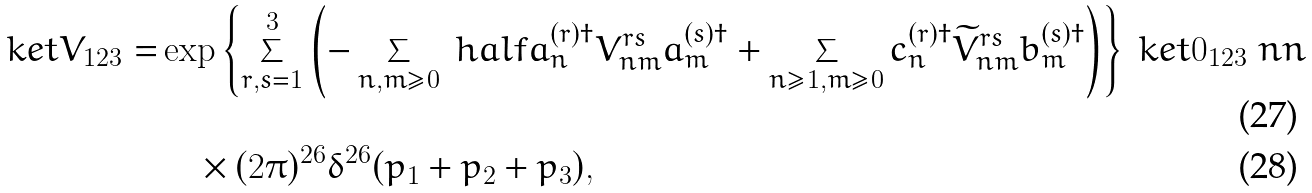<formula> <loc_0><loc_0><loc_500><loc_500>\ k e t { V } _ { 1 2 3 } = & \exp \left \{ \sum _ { r , s = 1 } ^ { 3 } \left ( - \sum _ { n , m \geq 0 } \ h a l f a _ { n } ^ { ( r ) \dagger } V _ { n m } ^ { r s } a _ { m } ^ { ( s ) \dagger } + \sum _ { n \geq 1 , m \geq 0 } c _ { n } ^ { ( r ) \dagger } \widetilde { V } _ { n m } ^ { r s } b _ { m } ^ { ( s ) \dagger } \right ) \right \} \ k e t { 0 } _ { 1 2 3 } \ n n \\ & \quad \times ( 2 \pi ) ^ { 2 6 } \delta ^ { 2 6 } ( p _ { 1 } + p _ { 2 } + p _ { 3 } ) ,</formula> 